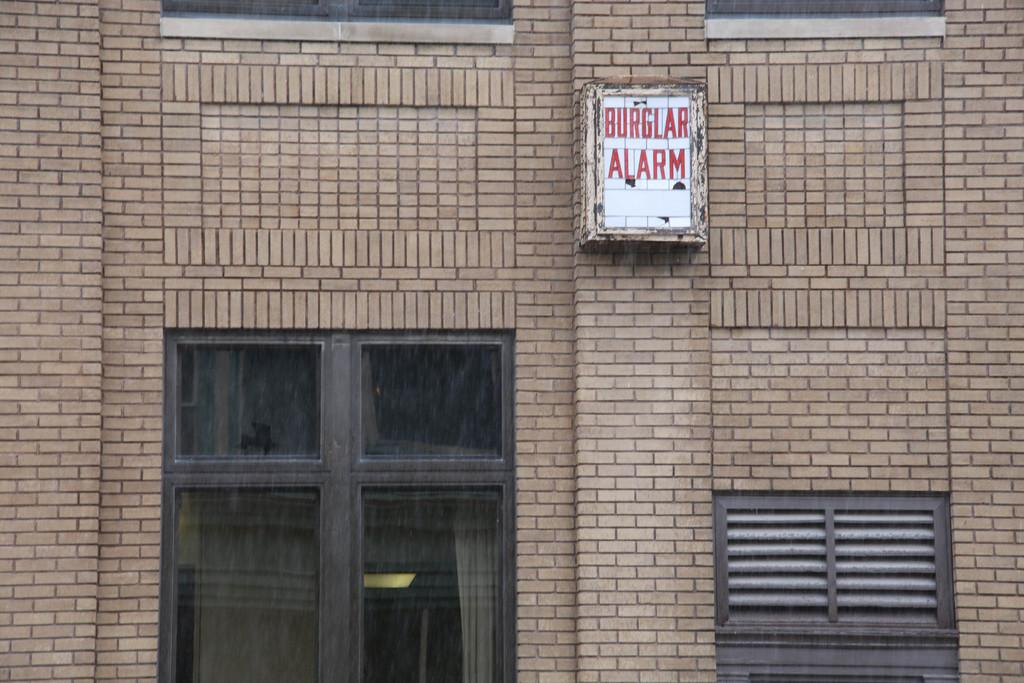What is the color of the building in the image? The building in the image is brown-colored. What type of window is present in front of the building? There is a glass window in front of the building. Is there any additional feature attached to the window? Yes, there is a white-colored board attached to the window. What type of insect is crawling on the attention-grabbing pan in the image? There is no insect or pan present in the image; it only features a brown-colored building with a glass window and a white-colored board attached to it. 